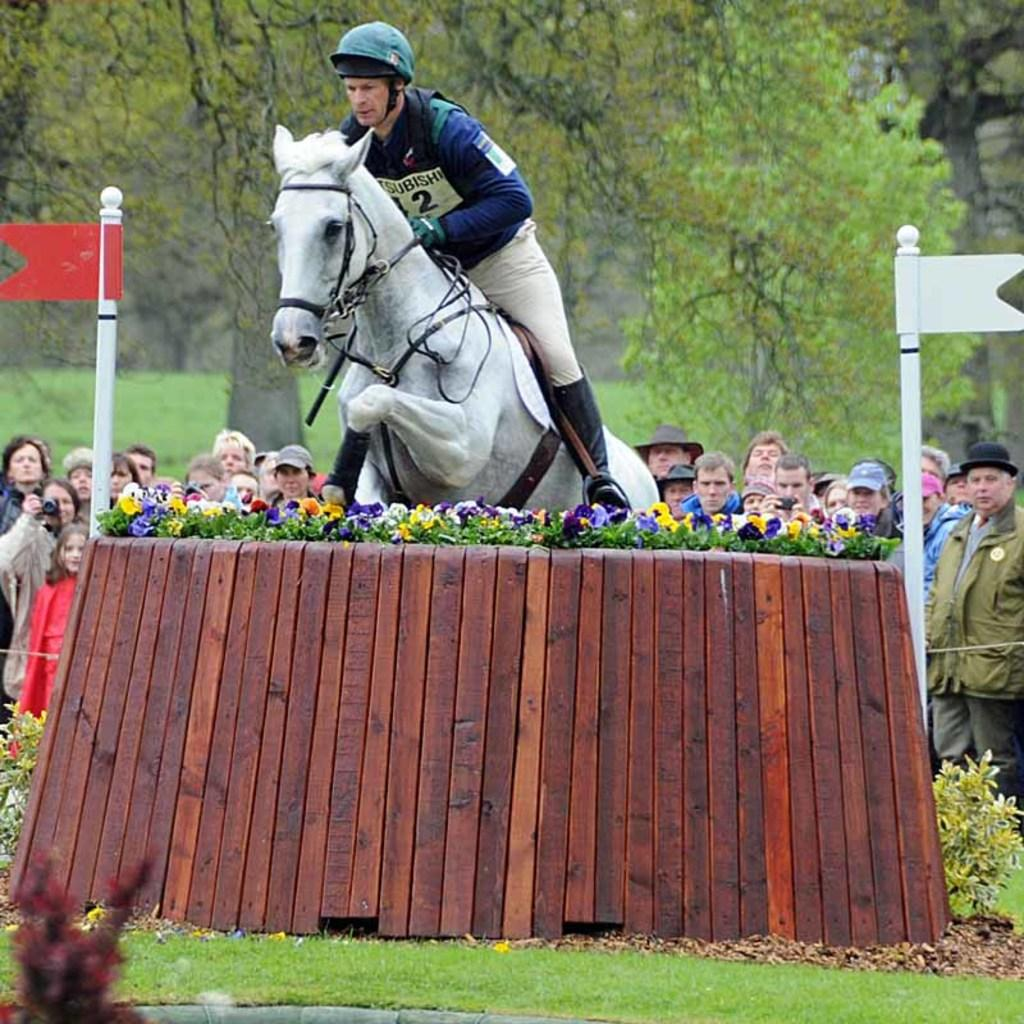What is the main action taking place in the image? There is a man riding a horse in the image, and he is jumping through a flower barricade. Who else is present in the image besides the man and the horse? There are people watching the event in the image. What can be seen in the background of the image? Trees are present in the background of the image. What type of bell can be heard ringing in the image? There is no bell present or audible in the image. What news is being reported in the image? There is no news being reported in the image; it depicts a man riding a horse and jumping through a flower barricade. 